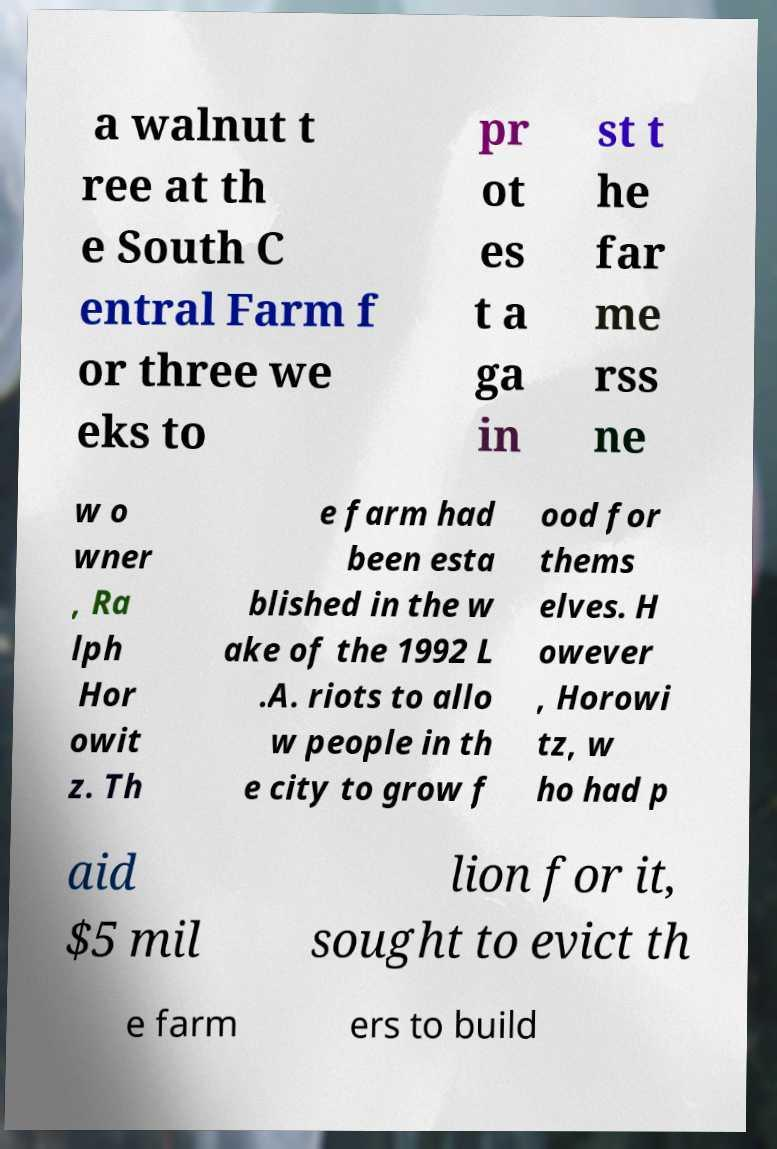What messages or text are displayed in this image? I need them in a readable, typed format. a walnut t ree at th e South C entral Farm f or three we eks to pr ot es t a ga in st t he far me rss ne w o wner , Ra lph Hor owit z. Th e farm had been esta blished in the w ake of the 1992 L .A. riots to allo w people in th e city to grow f ood for thems elves. H owever , Horowi tz, w ho had p aid $5 mil lion for it, sought to evict th e farm ers to build 